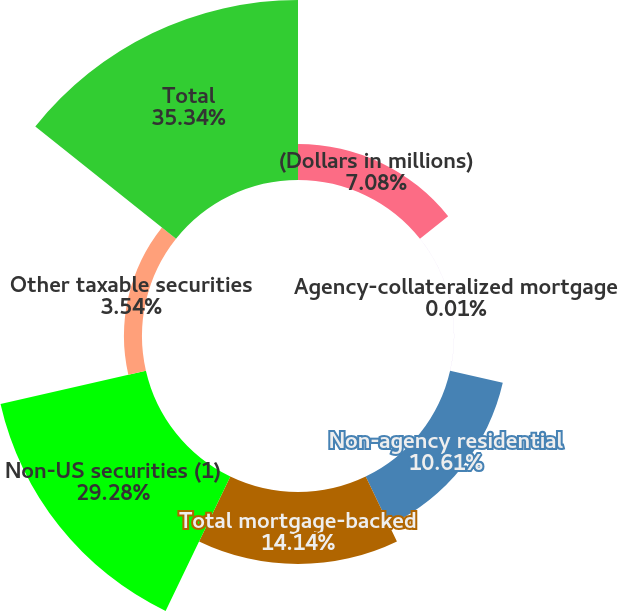Convert chart. <chart><loc_0><loc_0><loc_500><loc_500><pie_chart><fcel>(Dollars in millions)<fcel>Agency-collateralized mortgage<fcel>Non-agency residential<fcel>Total mortgage-backed<fcel>Non-US securities (1)<fcel>Other taxable securities<fcel>Total<nl><fcel>7.08%<fcel>0.01%<fcel>10.61%<fcel>14.14%<fcel>29.28%<fcel>3.54%<fcel>35.34%<nl></chart> 